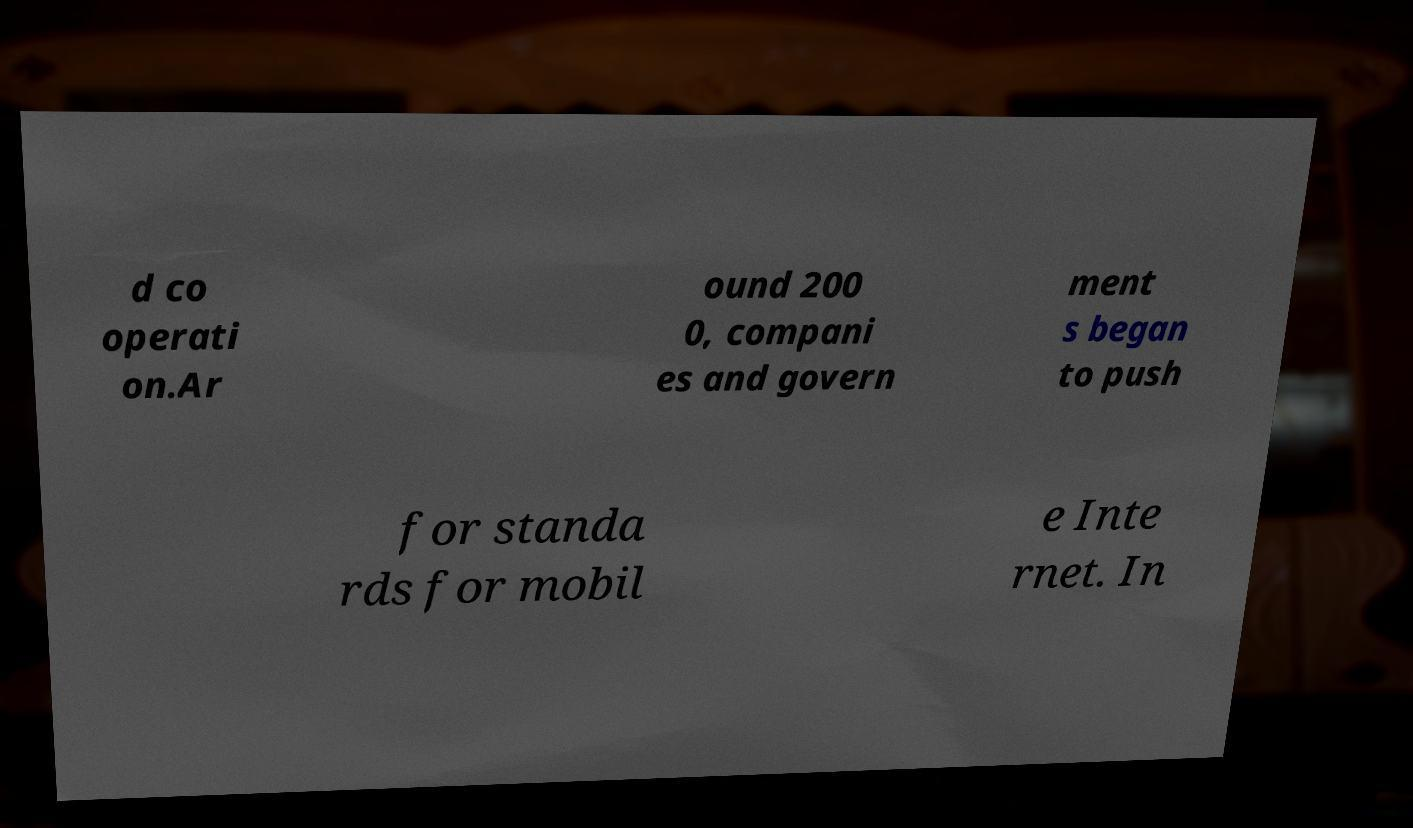I need the written content from this picture converted into text. Can you do that? d co operati on.Ar ound 200 0, compani es and govern ment s began to push for standa rds for mobil e Inte rnet. In 